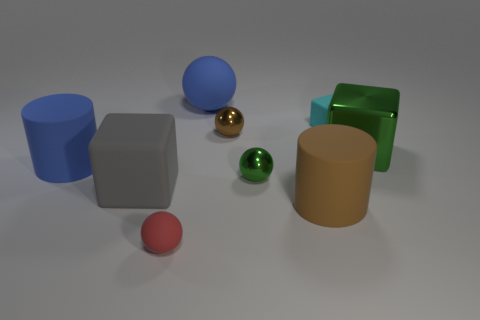How many cylinders are on the left side of the large blue thing that is in front of the small rubber cube?
Ensure brevity in your answer.  0. How many things are either brown things that are behind the large gray object or large yellow spheres?
Offer a terse response. 1. What number of large objects are the same material as the big gray cube?
Provide a succinct answer. 3. There is a tiny metal thing that is the same color as the big metallic thing; what shape is it?
Your answer should be very brief. Sphere. Are there an equal number of brown rubber cylinders that are behind the tiny brown thing and gray things?
Your response must be concise. No. What size is the matte block behind the green shiny ball?
Your answer should be very brief. Small. What number of small things are either brown metal cubes or rubber blocks?
Ensure brevity in your answer.  1. The other small shiny thing that is the same shape as the tiny green metal thing is what color?
Provide a short and direct response. Brown. Does the cyan block have the same size as the brown sphere?
Your response must be concise. Yes. How many things are either small brown shiny spheres or large gray rubber cubes that are left of the small cyan thing?
Provide a short and direct response. 2. 